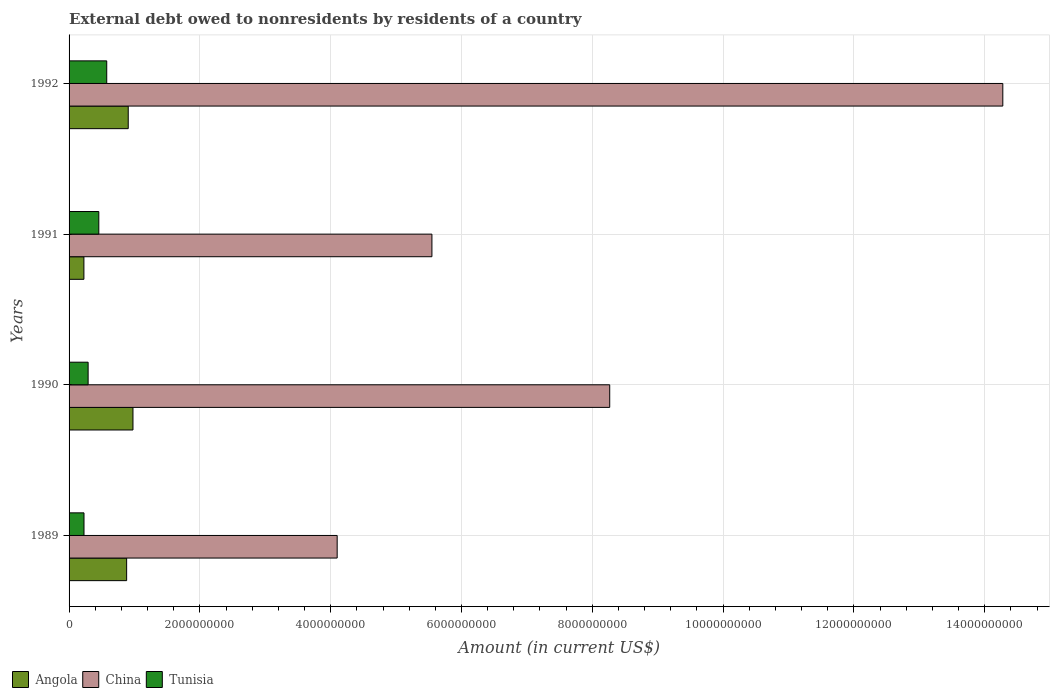How many different coloured bars are there?
Ensure brevity in your answer.  3. How many groups of bars are there?
Offer a terse response. 4. Are the number of bars per tick equal to the number of legend labels?
Keep it short and to the point. Yes. Are the number of bars on each tick of the Y-axis equal?
Your answer should be very brief. Yes. What is the label of the 2nd group of bars from the top?
Keep it short and to the point. 1991. What is the external debt owed by residents in Angola in 1992?
Your answer should be compact. 9.05e+08. Across all years, what is the maximum external debt owed by residents in Tunisia?
Provide a succinct answer. 5.76e+08. Across all years, what is the minimum external debt owed by residents in China?
Your answer should be very brief. 4.10e+09. In which year was the external debt owed by residents in Tunisia maximum?
Your answer should be very brief. 1992. In which year was the external debt owed by residents in Tunisia minimum?
Make the answer very short. 1989. What is the total external debt owed by residents in China in the graph?
Your answer should be compact. 3.22e+1. What is the difference between the external debt owed by residents in Tunisia in 1991 and that in 1992?
Offer a very short reply. -1.21e+08. What is the difference between the external debt owed by residents in Angola in 1991 and the external debt owed by residents in China in 1989?
Your answer should be compact. -3.87e+09. What is the average external debt owed by residents in China per year?
Offer a very short reply. 8.05e+09. In the year 1989, what is the difference between the external debt owed by residents in China and external debt owed by residents in Tunisia?
Offer a terse response. 3.87e+09. In how many years, is the external debt owed by residents in Angola greater than 14400000000 US$?
Provide a short and direct response. 0. What is the ratio of the external debt owed by residents in Tunisia in 1989 to that in 1990?
Offer a terse response. 0.78. Is the external debt owed by residents in China in 1989 less than that in 1991?
Your answer should be very brief. Yes. Is the difference between the external debt owed by residents in China in 1989 and 1991 greater than the difference between the external debt owed by residents in Tunisia in 1989 and 1991?
Provide a succinct answer. No. What is the difference between the highest and the second highest external debt owed by residents in China?
Make the answer very short. 6.01e+09. What is the difference between the highest and the lowest external debt owed by residents in China?
Offer a very short reply. 1.02e+1. In how many years, is the external debt owed by residents in Angola greater than the average external debt owed by residents in Angola taken over all years?
Ensure brevity in your answer.  3. Is the sum of the external debt owed by residents in China in 1989 and 1992 greater than the maximum external debt owed by residents in Tunisia across all years?
Offer a terse response. Yes. What does the 1st bar from the top in 1991 represents?
Ensure brevity in your answer.  Tunisia. What does the 3rd bar from the bottom in 1989 represents?
Ensure brevity in your answer.  Tunisia. Are all the bars in the graph horizontal?
Ensure brevity in your answer.  Yes. What is the difference between two consecutive major ticks on the X-axis?
Offer a very short reply. 2.00e+09. Are the values on the major ticks of X-axis written in scientific E-notation?
Your answer should be very brief. No. Does the graph contain grids?
Keep it short and to the point. Yes. Where does the legend appear in the graph?
Give a very brief answer. Bottom left. How many legend labels are there?
Provide a short and direct response. 3. How are the legend labels stacked?
Give a very brief answer. Horizontal. What is the title of the graph?
Your response must be concise. External debt owed to nonresidents by residents of a country. What is the Amount (in current US$) in Angola in 1989?
Your answer should be compact. 8.80e+08. What is the Amount (in current US$) in China in 1989?
Your answer should be compact. 4.10e+09. What is the Amount (in current US$) in Tunisia in 1989?
Offer a terse response. 2.28e+08. What is the Amount (in current US$) of Angola in 1990?
Make the answer very short. 9.77e+08. What is the Amount (in current US$) of China in 1990?
Give a very brief answer. 8.27e+09. What is the Amount (in current US$) of Tunisia in 1990?
Your response must be concise. 2.91e+08. What is the Amount (in current US$) of Angola in 1991?
Make the answer very short. 2.27e+08. What is the Amount (in current US$) of China in 1991?
Make the answer very short. 5.55e+09. What is the Amount (in current US$) in Tunisia in 1991?
Your response must be concise. 4.55e+08. What is the Amount (in current US$) of Angola in 1992?
Keep it short and to the point. 9.05e+08. What is the Amount (in current US$) of China in 1992?
Keep it short and to the point. 1.43e+1. What is the Amount (in current US$) of Tunisia in 1992?
Provide a succinct answer. 5.76e+08. Across all years, what is the maximum Amount (in current US$) in Angola?
Offer a very short reply. 9.77e+08. Across all years, what is the maximum Amount (in current US$) in China?
Make the answer very short. 1.43e+1. Across all years, what is the maximum Amount (in current US$) of Tunisia?
Provide a succinct answer. 5.76e+08. Across all years, what is the minimum Amount (in current US$) in Angola?
Ensure brevity in your answer.  2.27e+08. Across all years, what is the minimum Amount (in current US$) of China?
Your response must be concise. 4.10e+09. Across all years, what is the minimum Amount (in current US$) of Tunisia?
Make the answer very short. 2.28e+08. What is the total Amount (in current US$) in Angola in the graph?
Your response must be concise. 2.99e+09. What is the total Amount (in current US$) in China in the graph?
Give a very brief answer. 3.22e+1. What is the total Amount (in current US$) of Tunisia in the graph?
Keep it short and to the point. 1.55e+09. What is the difference between the Amount (in current US$) in Angola in 1989 and that in 1990?
Your answer should be very brief. -9.70e+07. What is the difference between the Amount (in current US$) in China in 1989 and that in 1990?
Give a very brief answer. -4.17e+09. What is the difference between the Amount (in current US$) of Tunisia in 1989 and that in 1990?
Give a very brief answer. -6.31e+07. What is the difference between the Amount (in current US$) of Angola in 1989 and that in 1991?
Offer a very short reply. 6.53e+08. What is the difference between the Amount (in current US$) in China in 1989 and that in 1991?
Provide a short and direct response. -1.45e+09. What is the difference between the Amount (in current US$) of Tunisia in 1989 and that in 1991?
Make the answer very short. -2.26e+08. What is the difference between the Amount (in current US$) of Angola in 1989 and that in 1992?
Offer a very short reply. -2.44e+07. What is the difference between the Amount (in current US$) of China in 1989 and that in 1992?
Your response must be concise. -1.02e+1. What is the difference between the Amount (in current US$) of Tunisia in 1989 and that in 1992?
Provide a succinct answer. -3.48e+08. What is the difference between the Amount (in current US$) in Angola in 1990 and that in 1991?
Offer a terse response. 7.50e+08. What is the difference between the Amount (in current US$) in China in 1990 and that in 1991?
Ensure brevity in your answer.  2.72e+09. What is the difference between the Amount (in current US$) in Tunisia in 1990 and that in 1991?
Offer a terse response. -1.63e+08. What is the difference between the Amount (in current US$) in Angola in 1990 and that in 1992?
Offer a terse response. 7.26e+07. What is the difference between the Amount (in current US$) of China in 1990 and that in 1992?
Make the answer very short. -6.01e+09. What is the difference between the Amount (in current US$) of Tunisia in 1990 and that in 1992?
Give a very brief answer. -2.84e+08. What is the difference between the Amount (in current US$) of Angola in 1991 and that in 1992?
Offer a very short reply. -6.78e+08. What is the difference between the Amount (in current US$) in China in 1991 and that in 1992?
Keep it short and to the point. -8.73e+09. What is the difference between the Amount (in current US$) in Tunisia in 1991 and that in 1992?
Your answer should be very brief. -1.21e+08. What is the difference between the Amount (in current US$) of Angola in 1989 and the Amount (in current US$) of China in 1990?
Offer a very short reply. -7.39e+09. What is the difference between the Amount (in current US$) in Angola in 1989 and the Amount (in current US$) in Tunisia in 1990?
Make the answer very short. 5.89e+08. What is the difference between the Amount (in current US$) in China in 1989 and the Amount (in current US$) in Tunisia in 1990?
Make the answer very short. 3.81e+09. What is the difference between the Amount (in current US$) in Angola in 1989 and the Amount (in current US$) in China in 1991?
Your answer should be very brief. -4.67e+09. What is the difference between the Amount (in current US$) of Angola in 1989 and the Amount (in current US$) of Tunisia in 1991?
Keep it short and to the point. 4.25e+08. What is the difference between the Amount (in current US$) of China in 1989 and the Amount (in current US$) of Tunisia in 1991?
Provide a short and direct response. 3.64e+09. What is the difference between the Amount (in current US$) in Angola in 1989 and the Amount (in current US$) in China in 1992?
Offer a very short reply. -1.34e+1. What is the difference between the Amount (in current US$) of Angola in 1989 and the Amount (in current US$) of Tunisia in 1992?
Make the answer very short. 3.04e+08. What is the difference between the Amount (in current US$) in China in 1989 and the Amount (in current US$) in Tunisia in 1992?
Ensure brevity in your answer.  3.52e+09. What is the difference between the Amount (in current US$) of Angola in 1990 and the Amount (in current US$) of China in 1991?
Offer a very short reply. -4.57e+09. What is the difference between the Amount (in current US$) of Angola in 1990 and the Amount (in current US$) of Tunisia in 1991?
Your response must be concise. 5.22e+08. What is the difference between the Amount (in current US$) of China in 1990 and the Amount (in current US$) of Tunisia in 1991?
Provide a succinct answer. 7.81e+09. What is the difference between the Amount (in current US$) in Angola in 1990 and the Amount (in current US$) in China in 1992?
Your answer should be compact. -1.33e+1. What is the difference between the Amount (in current US$) of Angola in 1990 and the Amount (in current US$) of Tunisia in 1992?
Make the answer very short. 4.01e+08. What is the difference between the Amount (in current US$) of China in 1990 and the Amount (in current US$) of Tunisia in 1992?
Offer a terse response. 7.69e+09. What is the difference between the Amount (in current US$) of Angola in 1991 and the Amount (in current US$) of China in 1992?
Your answer should be very brief. -1.41e+1. What is the difference between the Amount (in current US$) in Angola in 1991 and the Amount (in current US$) in Tunisia in 1992?
Offer a terse response. -3.49e+08. What is the difference between the Amount (in current US$) in China in 1991 and the Amount (in current US$) in Tunisia in 1992?
Provide a succinct answer. 4.97e+09. What is the average Amount (in current US$) in Angola per year?
Make the answer very short. 7.47e+08. What is the average Amount (in current US$) in China per year?
Make the answer very short. 8.05e+09. What is the average Amount (in current US$) of Tunisia per year?
Your answer should be very brief. 3.88e+08. In the year 1989, what is the difference between the Amount (in current US$) of Angola and Amount (in current US$) of China?
Your answer should be compact. -3.22e+09. In the year 1989, what is the difference between the Amount (in current US$) in Angola and Amount (in current US$) in Tunisia?
Provide a short and direct response. 6.52e+08. In the year 1989, what is the difference between the Amount (in current US$) in China and Amount (in current US$) in Tunisia?
Keep it short and to the point. 3.87e+09. In the year 1990, what is the difference between the Amount (in current US$) in Angola and Amount (in current US$) in China?
Offer a very short reply. -7.29e+09. In the year 1990, what is the difference between the Amount (in current US$) in Angola and Amount (in current US$) in Tunisia?
Your response must be concise. 6.86e+08. In the year 1990, what is the difference between the Amount (in current US$) of China and Amount (in current US$) of Tunisia?
Your answer should be compact. 7.98e+09. In the year 1991, what is the difference between the Amount (in current US$) of Angola and Amount (in current US$) of China?
Provide a succinct answer. -5.32e+09. In the year 1991, what is the difference between the Amount (in current US$) in Angola and Amount (in current US$) in Tunisia?
Provide a succinct answer. -2.28e+08. In the year 1991, what is the difference between the Amount (in current US$) in China and Amount (in current US$) in Tunisia?
Ensure brevity in your answer.  5.09e+09. In the year 1992, what is the difference between the Amount (in current US$) of Angola and Amount (in current US$) of China?
Offer a very short reply. -1.34e+1. In the year 1992, what is the difference between the Amount (in current US$) of Angola and Amount (in current US$) of Tunisia?
Offer a terse response. 3.29e+08. In the year 1992, what is the difference between the Amount (in current US$) in China and Amount (in current US$) in Tunisia?
Offer a terse response. 1.37e+1. What is the ratio of the Amount (in current US$) of Angola in 1989 to that in 1990?
Your answer should be very brief. 0.9. What is the ratio of the Amount (in current US$) in China in 1989 to that in 1990?
Give a very brief answer. 0.5. What is the ratio of the Amount (in current US$) in Tunisia in 1989 to that in 1990?
Provide a succinct answer. 0.78. What is the ratio of the Amount (in current US$) in Angola in 1989 to that in 1991?
Your response must be concise. 3.88. What is the ratio of the Amount (in current US$) in China in 1989 to that in 1991?
Offer a terse response. 0.74. What is the ratio of the Amount (in current US$) of Tunisia in 1989 to that in 1991?
Your answer should be compact. 0.5. What is the ratio of the Amount (in current US$) of Angola in 1989 to that in 1992?
Ensure brevity in your answer.  0.97. What is the ratio of the Amount (in current US$) in China in 1989 to that in 1992?
Offer a very short reply. 0.29. What is the ratio of the Amount (in current US$) of Tunisia in 1989 to that in 1992?
Ensure brevity in your answer.  0.4. What is the ratio of the Amount (in current US$) in Angola in 1990 to that in 1991?
Make the answer very short. 4.31. What is the ratio of the Amount (in current US$) of China in 1990 to that in 1991?
Provide a short and direct response. 1.49. What is the ratio of the Amount (in current US$) of Tunisia in 1990 to that in 1991?
Make the answer very short. 0.64. What is the ratio of the Amount (in current US$) of Angola in 1990 to that in 1992?
Ensure brevity in your answer.  1.08. What is the ratio of the Amount (in current US$) of China in 1990 to that in 1992?
Your answer should be compact. 0.58. What is the ratio of the Amount (in current US$) in Tunisia in 1990 to that in 1992?
Provide a short and direct response. 0.51. What is the ratio of the Amount (in current US$) of Angola in 1991 to that in 1992?
Offer a very short reply. 0.25. What is the ratio of the Amount (in current US$) of China in 1991 to that in 1992?
Offer a terse response. 0.39. What is the ratio of the Amount (in current US$) in Tunisia in 1991 to that in 1992?
Provide a succinct answer. 0.79. What is the difference between the highest and the second highest Amount (in current US$) of Angola?
Your response must be concise. 7.26e+07. What is the difference between the highest and the second highest Amount (in current US$) in China?
Keep it short and to the point. 6.01e+09. What is the difference between the highest and the second highest Amount (in current US$) in Tunisia?
Provide a succinct answer. 1.21e+08. What is the difference between the highest and the lowest Amount (in current US$) in Angola?
Ensure brevity in your answer.  7.50e+08. What is the difference between the highest and the lowest Amount (in current US$) in China?
Your answer should be compact. 1.02e+1. What is the difference between the highest and the lowest Amount (in current US$) in Tunisia?
Keep it short and to the point. 3.48e+08. 